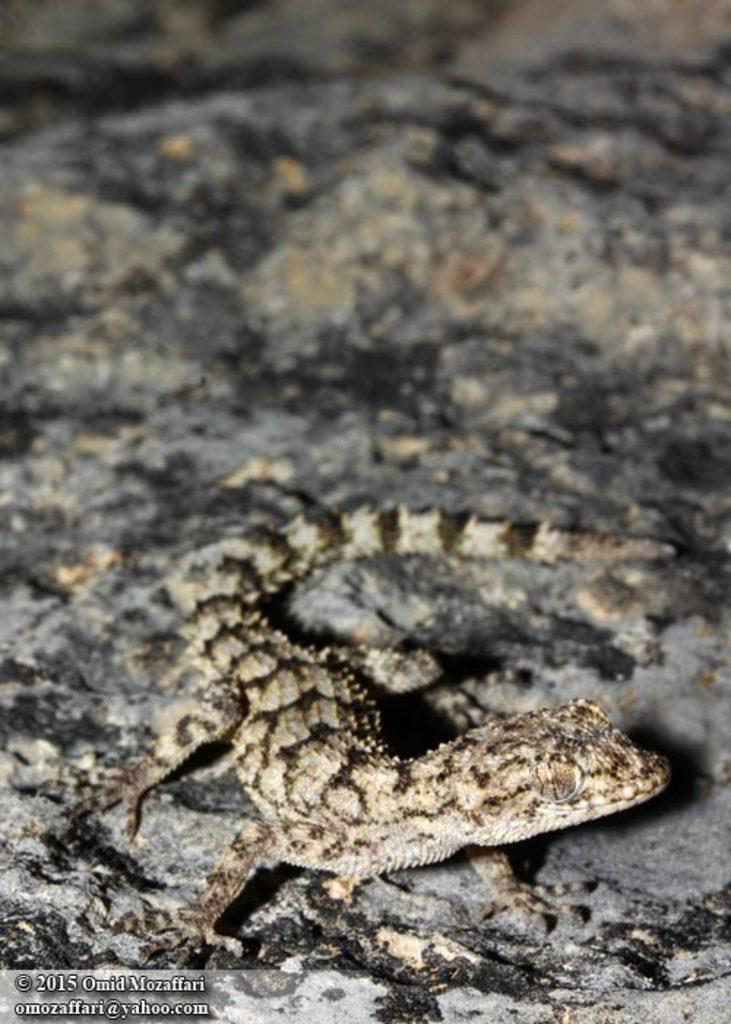What is the main subject in the center of the image? There is a lizard in the center of the image. What can be seen at the bottom of the image? There is a walkway at the bottom of the image. How many geese are flying in the image? There are no geese present in the image. What type of voyage is depicted in the image? The image does not depict any voyage; it features a lizard and a walkway. 